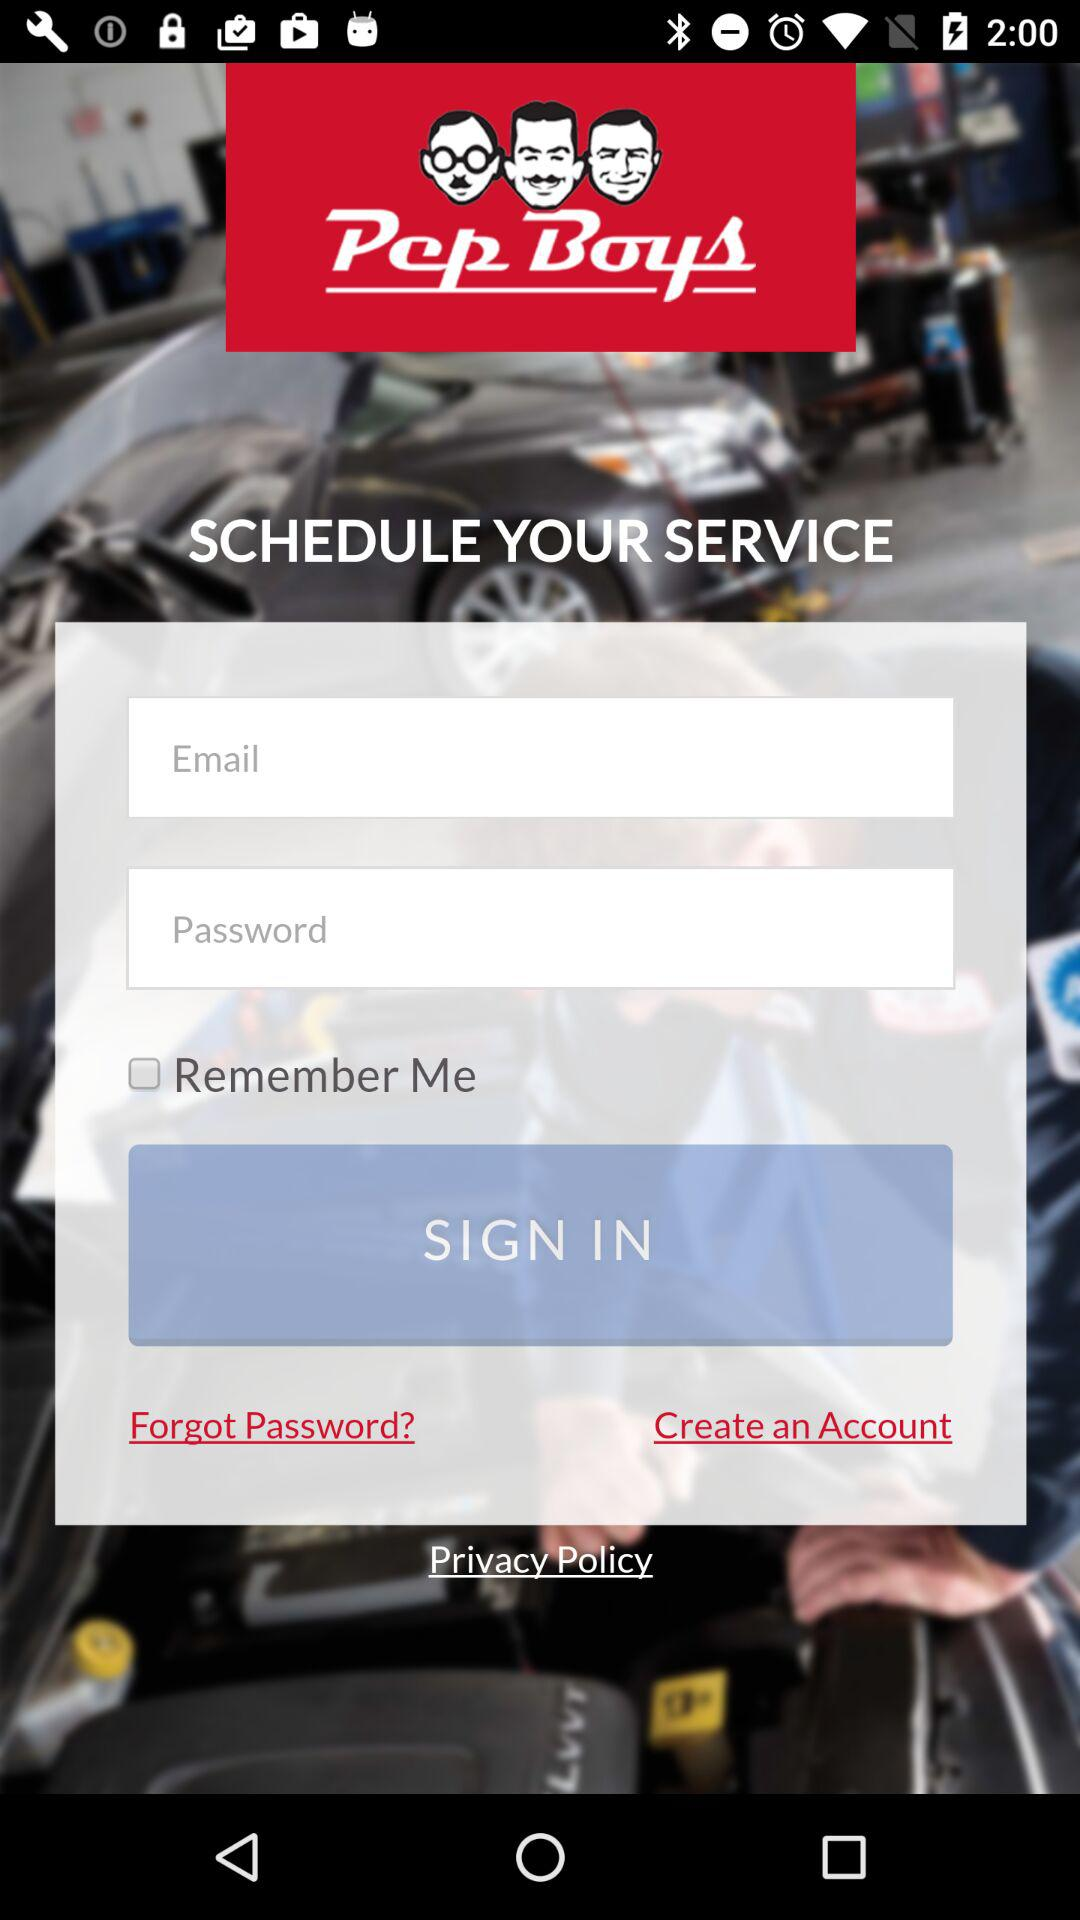How many text inputs are there for the sign in form?
Answer the question using a single word or phrase. 2 